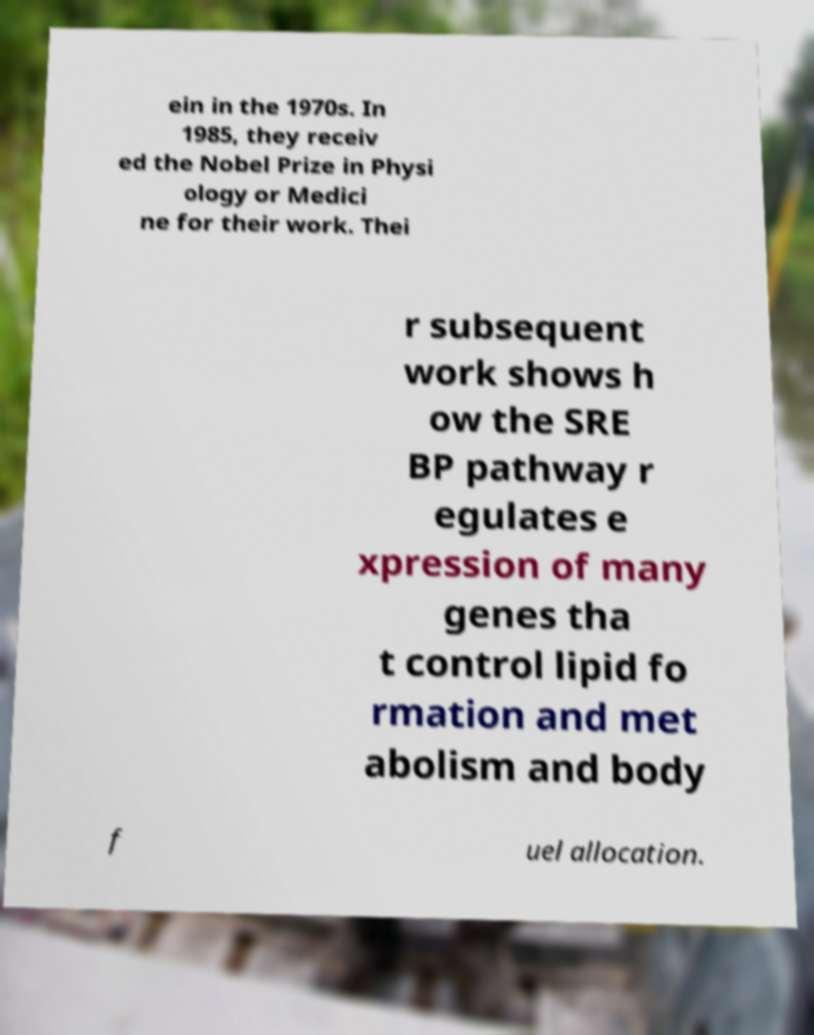Please read and relay the text visible in this image. What does it say? ein in the 1970s. In 1985, they receiv ed the Nobel Prize in Physi ology or Medici ne for their work. Thei r subsequent work shows h ow the SRE BP pathway r egulates e xpression of many genes tha t control lipid fo rmation and met abolism and body f uel allocation. 